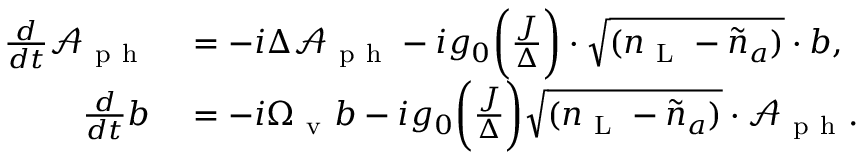<formula> <loc_0><loc_0><loc_500><loc_500>\begin{array} { r l } { \frac { d } { d t } \mathcal { A } _ { p h } } & = - i \Delta \mathcal { A } _ { p h } - i g _ { 0 } \left ( \frac { J } { \Delta } \right ) \cdot \sqrt { ( { n } _ { L } - \tilde { n } _ { a } ) } \cdot b , } \\ { \frac { d } { d t } b } & = - i \Omega _ { v } b - i g _ { 0 } \left ( \frac { J } { \Delta } \right ) \sqrt { ( { n } _ { L } - \tilde { n } _ { a } ) } \cdot \mathcal { A } _ { p h } . } \end{array}</formula> 